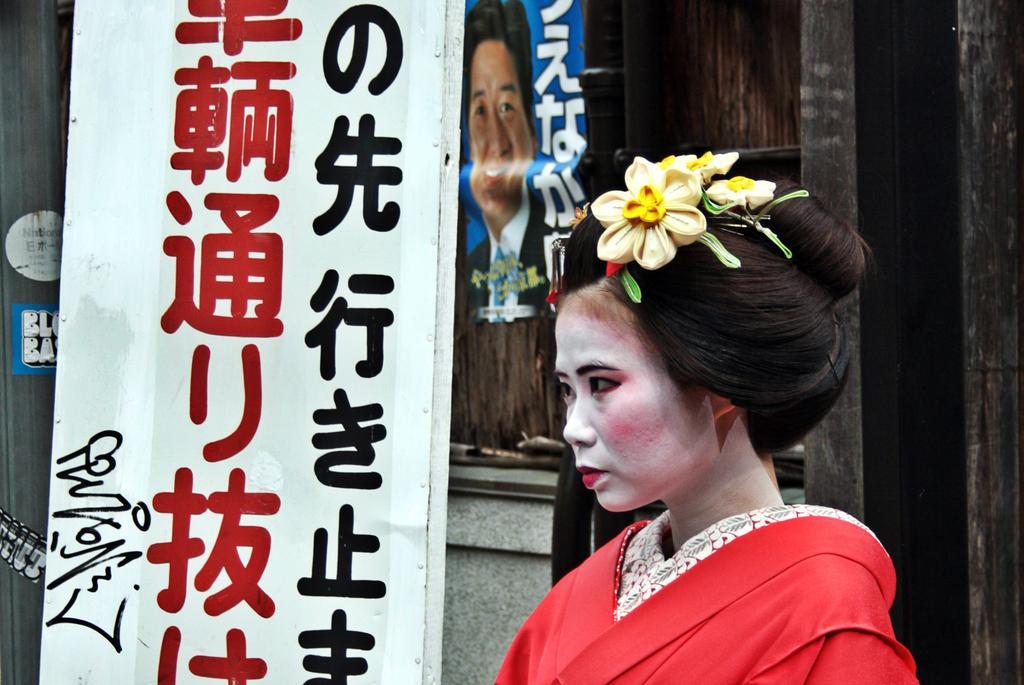In one or two sentences, can you explain what this image depicts? In this image there is a woman having few flowers on her head. Left side there is a banner. Beside there is a pole. Background there is a wall having a poster attached to it. On the poster there is an image of a person. 